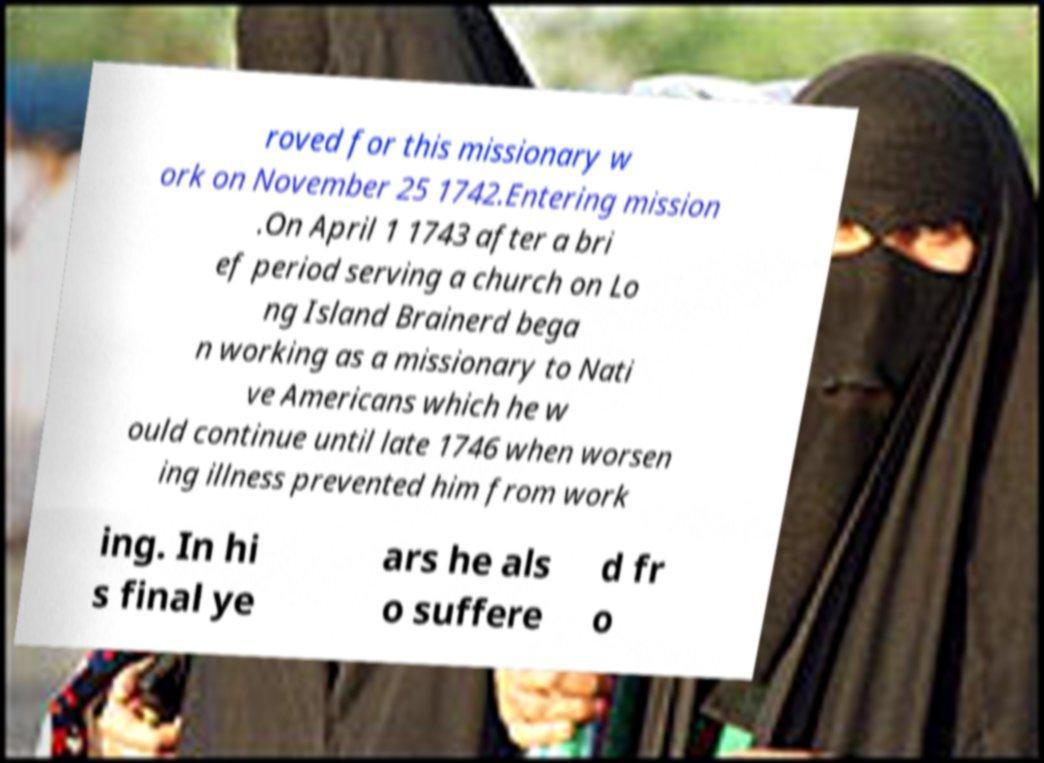Please identify and transcribe the text found in this image. roved for this missionary w ork on November 25 1742.Entering mission .On April 1 1743 after a bri ef period serving a church on Lo ng Island Brainerd bega n working as a missionary to Nati ve Americans which he w ould continue until late 1746 when worsen ing illness prevented him from work ing. In hi s final ye ars he als o suffere d fr o 